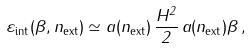<formula> <loc_0><loc_0><loc_500><loc_500>\varepsilon _ { \text {int} } ( \beta , n _ { \text {ext} } ) \simeq a ( n _ { \text {ext} } ) \, \frac { H ^ { 2 } } { 2 } \, a ( n _ { \text {ext} } ) \beta \, ,</formula> 